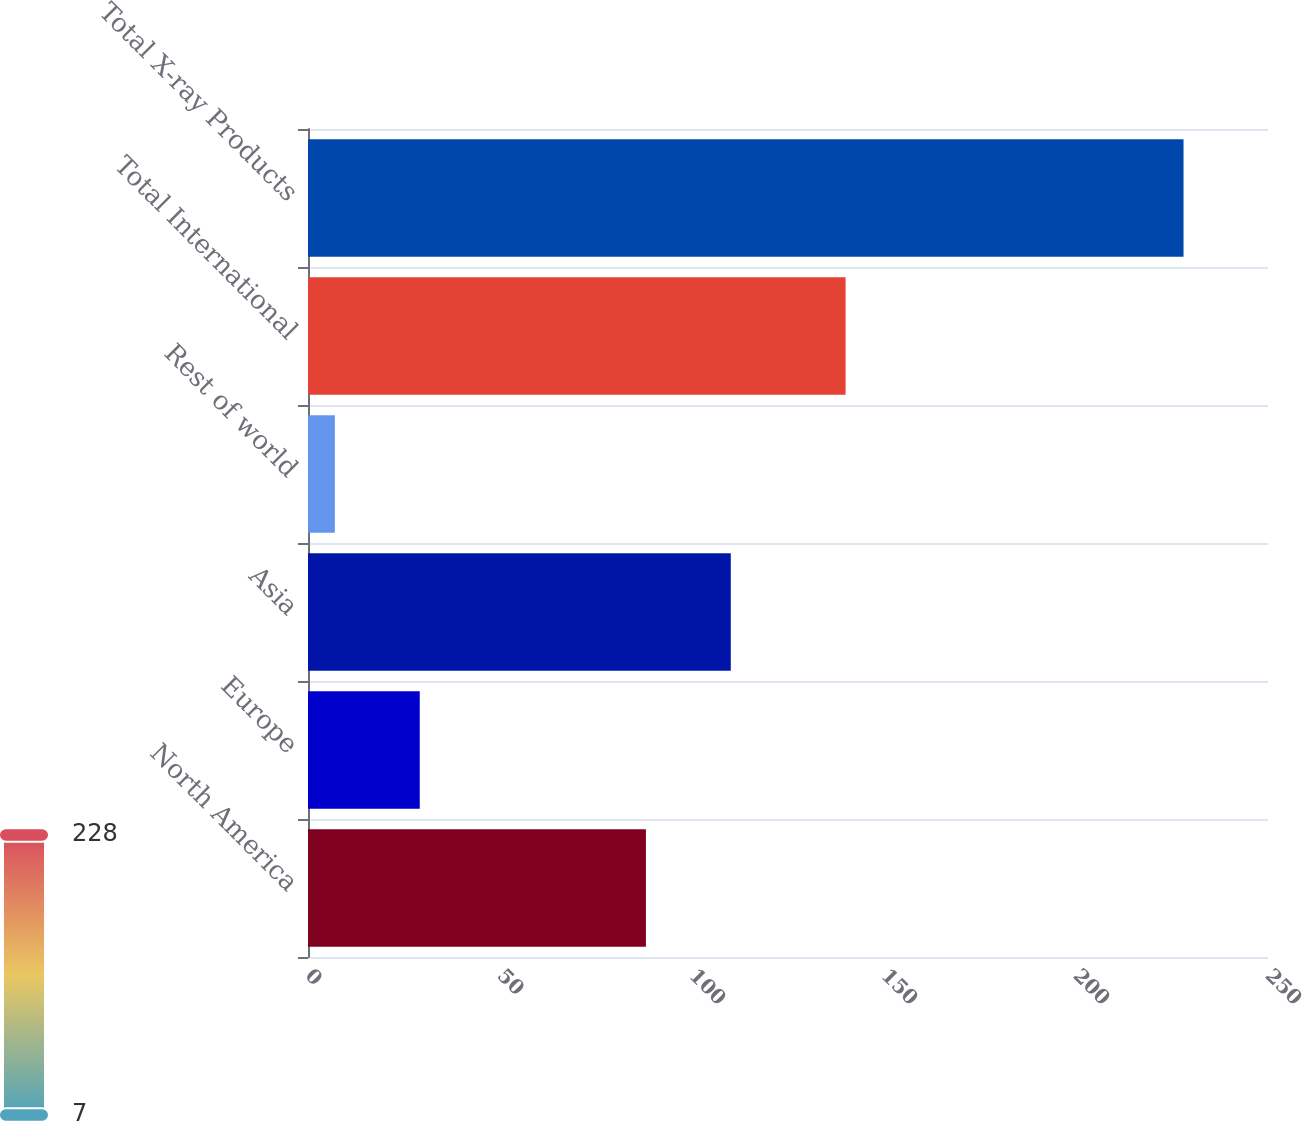<chart> <loc_0><loc_0><loc_500><loc_500><bar_chart><fcel>North America<fcel>Europe<fcel>Asia<fcel>Rest of world<fcel>Total International<fcel>Total X-ray Products<nl><fcel>88<fcel>29.1<fcel>110.1<fcel>7<fcel>140<fcel>228<nl></chart> 